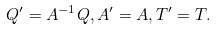Convert formula to latex. <formula><loc_0><loc_0><loc_500><loc_500>Q ^ { \prime } = A ^ { - 1 } Q , A ^ { \prime } = A , T ^ { \prime } = T .</formula> 